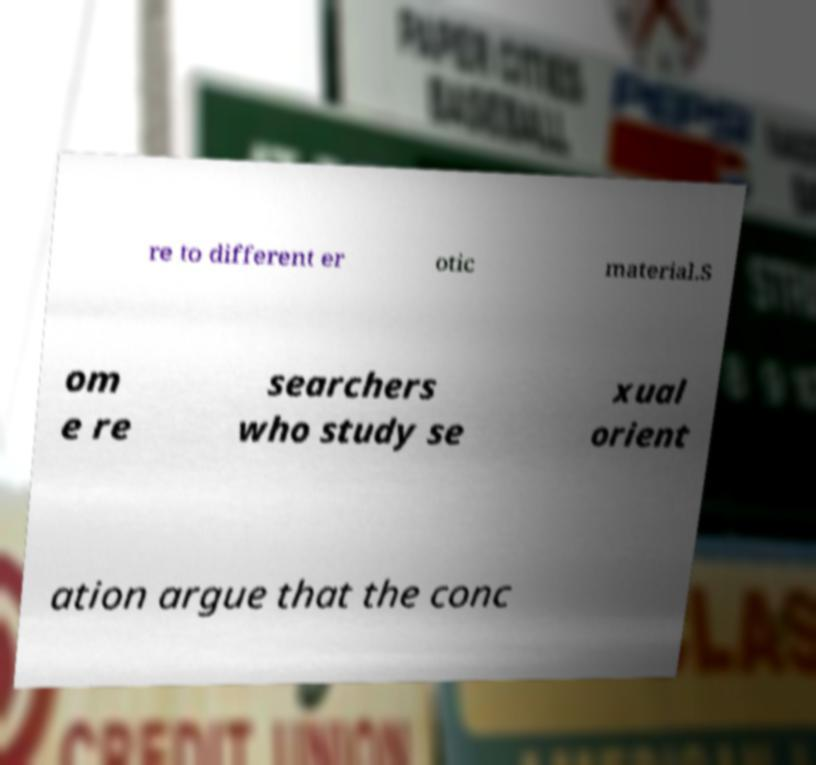Could you extract and type out the text from this image? re to different er otic material.S om e re searchers who study se xual orient ation argue that the conc 